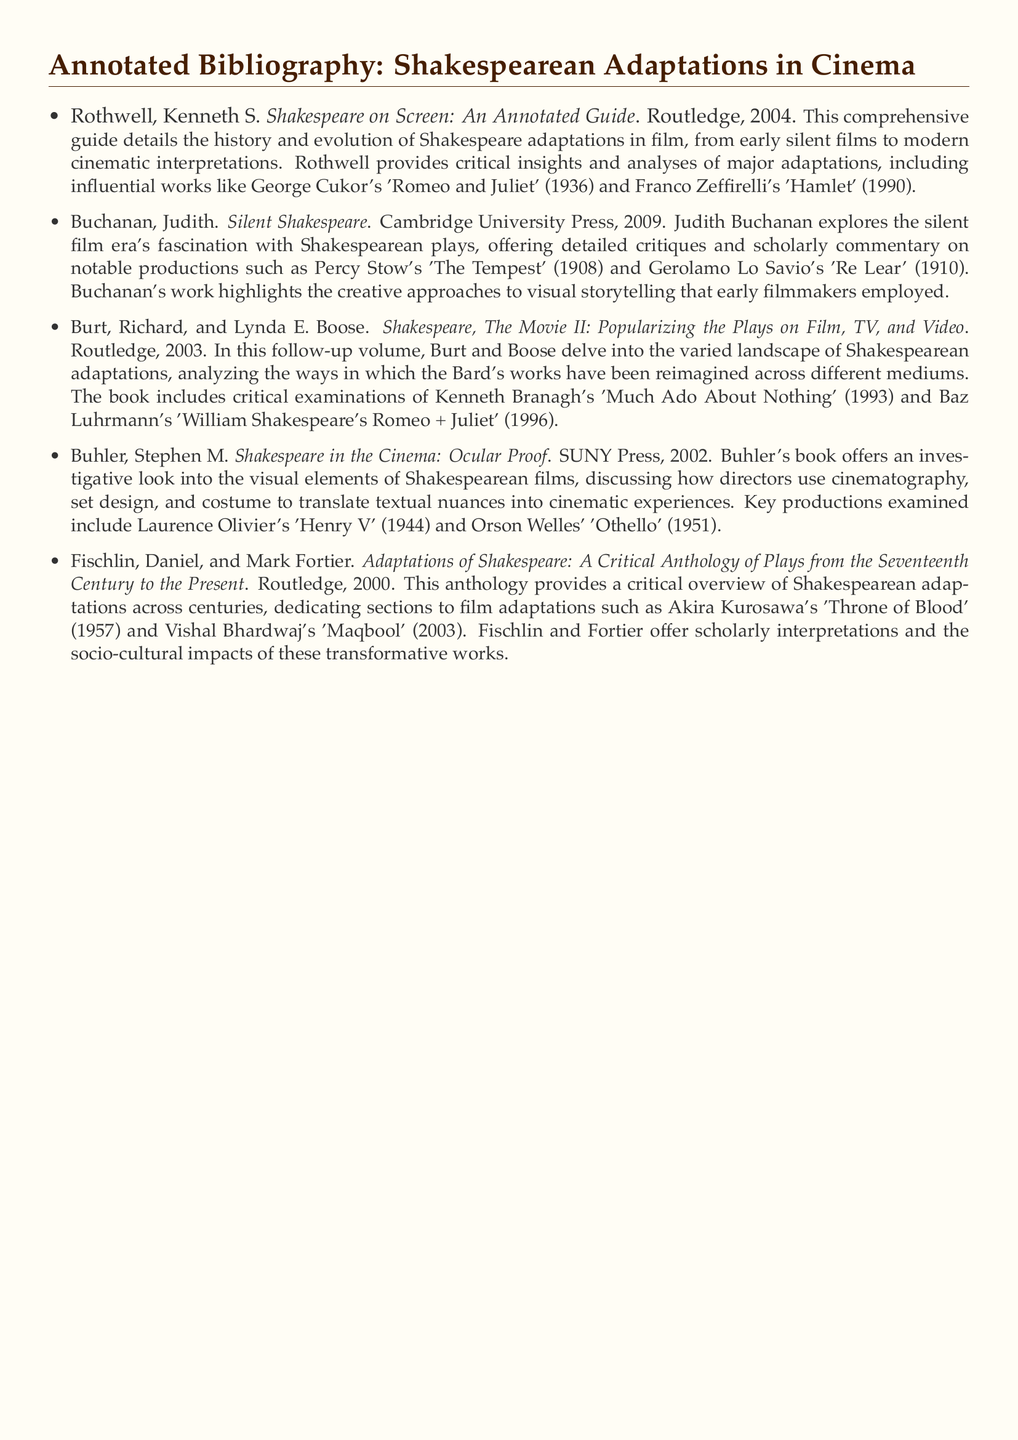What is the title of Rothwell's book? Rothwell's book is listed in the bibliography, and its title is explicitly given.
Answer: Shakespeare on Screen: An Annotated Guide Who is the author of "Silent Shakespeare"? The author of the book "Silent Shakespeare" is mentioned directly in the document.
Answer: Judith Buchanan In what year was "Shakespeare, The Movie II" published? The publication year of "Shakespeare, The Movie II" is provided within the bibliographic entry.
Answer: 2003 Which film does Buhler's book examine? Buhler's book discusses specific films, and one of them is mentioned directly in the bibliographic entry.
Answer: Henry V What is the focus of Fischlin and Fortier's anthology? The focus of Fischlin and Fortier's anthology includes the examination of adaptations, specifically referencing a thematic aspect outlined in the document.
Answer: Adaptations of Shakespeare What type of films does Buchanan's work analyze? Buchanan's work specifies the type of films that she critiques, based on the document.
Answer: Silent films Which adaptation is noted as being from the seventeenth century to the present? The bibliographic entry mentions a particular timeframe for the adaptations being analyzed, linking it to the works discussed.
Answer: Adaptations of Shakespeare How many works are included in the displayed annotations? The number of works noted in the annotated bibliography can be counted from the entries listed in the document.
Answer: Five 